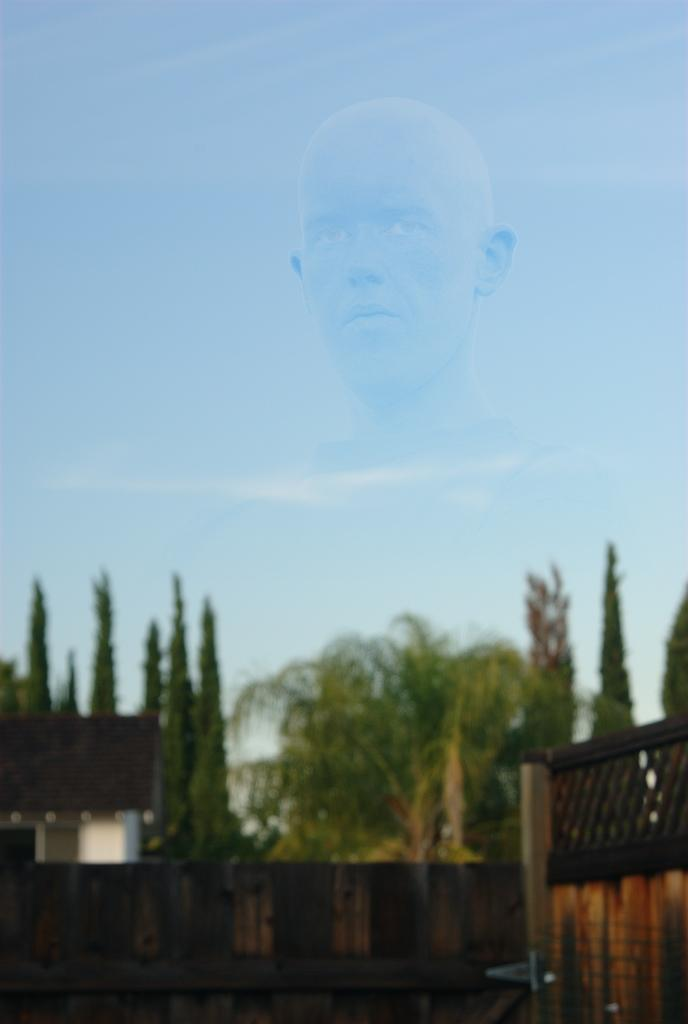What type of structures can be seen in the image? There are buildings in the image. What other natural elements are present in the image? There are trees in the image. What can be seen in the sky in the image? The sky is visible in the image, and there are clouds in the sky. Is there any additional detail in the sky? Yes, there is a picture of a person in the sky. What type of road can be seen in the image? There is no road present in the image. Can you describe the gate in the image? There is no gate present in the image. 